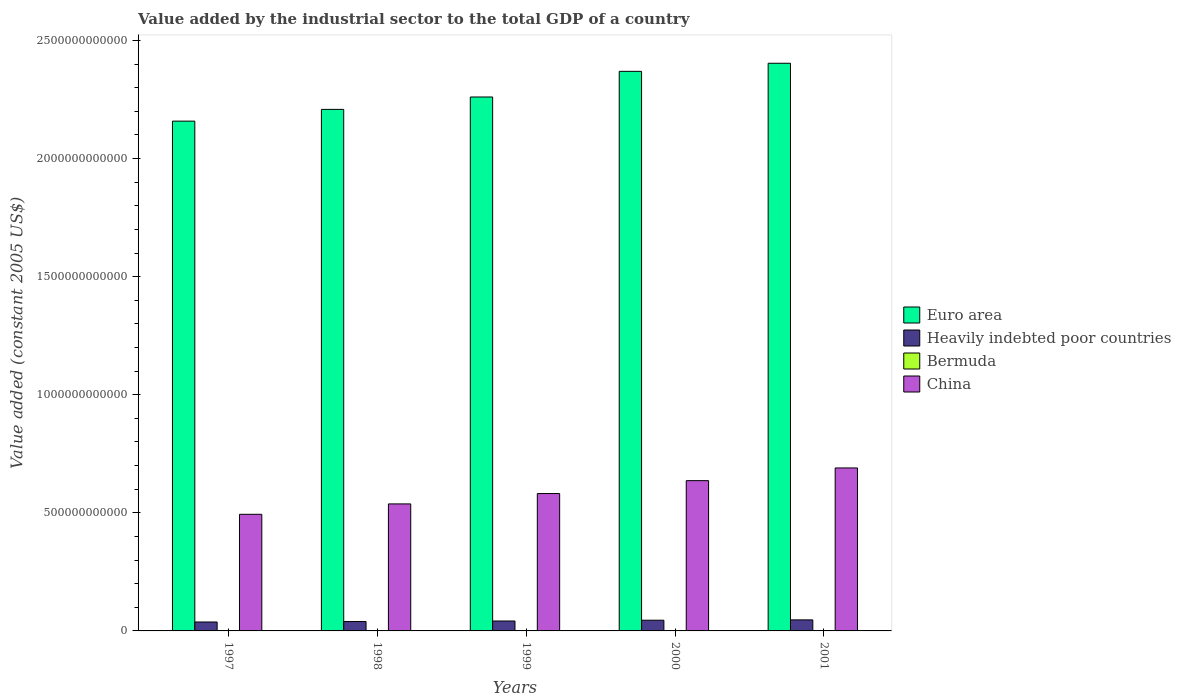How many different coloured bars are there?
Ensure brevity in your answer.  4. Are the number of bars on each tick of the X-axis equal?
Your answer should be compact. Yes. What is the label of the 3rd group of bars from the left?
Provide a short and direct response. 1999. In how many cases, is the number of bars for a given year not equal to the number of legend labels?
Keep it short and to the point. 0. What is the value added by the industrial sector in Heavily indebted poor countries in 2001?
Provide a succinct answer. 4.68e+1. Across all years, what is the maximum value added by the industrial sector in Euro area?
Your response must be concise. 2.40e+12. Across all years, what is the minimum value added by the industrial sector in Heavily indebted poor countries?
Provide a succinct answer. 3.78e+1. What is the total value added by the industrial sector in Heavily indebted poor countries in the graph?
Offer a terse response. 2.12e+11. What is the difference between the value added by the industrial sector in China in 1999 and that in 2000?
Keep it short and to the point. -5.47e+1. What is the difference between the value added by the industrial sector in Euro area in 1997 and the value added by the industrial sector in Bermuda in 1998?
Your response must be concise. 2.16e+12. What is the average value added by the industrial sector in Euro area per year?
Provide a short and direct response. 2.28e+12. In the year 2001, what is the difference between the value added by the industrial sector in Euro area and value added by the industrial sector in China?
Provide a short and direct response. 1.71e+12. What is the ratio of the value added by the industrial sector in Heavily indebted poor countries in 1997 to that in 2001?
Offer a terse response. 0.81. Is the difference between the value added by the industrial sector in Euro area in 2000 and 2001 greater than the difference between the value added by the industrial sector in China in 2000 and 2001?
Your response must be concise. Yes. What is the difference between the highest and the second highest value added by the industrial sector in China?
Offer a terse response. 5.38e+1. What is the difference between the highest and the lowest value added by the industrial sector in China?
Offer a very short reply. 1.96e+11. Is the sum of the value added by the industrial sector in Euro area in 1997 and 2001 greater than the maximum value added by the industrial sector in China across all years?
Offer a very short reply. Yes. What does the 4th bar from the left in 2001 represents?
Offer a terse response. China. What does the 3rd bar from the right in 1998 represents?
Your answer should be very brief. Heavily indebted poor countries. Is it the case that in every year, the sum of the value added by the industrial sector in Bermuda and value added by the industrial sector in Heavily indebted poor countries is greater than the value added by the industrial sector in China?
Your answer should be compact. No. What is the difference between two consecutive major ticks on the Y-axis?
Your response must be concise. 5.00e+11. Are the values on the major ticks of Y-axis written in scientific E-notation?
Keep it short and to the point. No. Does the graph contain grids?
Your answer should be very brief. No. How many legend labels are there?
Your answer should be compact. 4. What is the title of the graph?
Provide a short and direct response. Value added by the industrial sector to the total GDP of a country. Does "Tajikistan" appear as one of the legend labels in the graph?
Offer a terse response. No. What is the label or title of the Y-axis?
Make the answer very short. Value added (constant 2005 US$). What is the Value added (constant 2005 US$) of Euro area in 1997?
Your answer should be very brief. 2.16e+12. What is the Value added (constant 2005 US$) in Heavily indebted poor countries in 1997?
Ensure brevity in your answer.  3.78e+1. What is the Value added (constant 2005 US$) in Bermuda in 1997?
Ensure brevity in your answer.  3.66e+08. What is the Value added (constant 2005 US$) of China in 1997?
Give a very brief answer. 4.94e+11. What is the Value added (constant 2005 US$) of Euro area in 1998?
Your answer should be compact. 2.21e+12. What is the Value added (constant 2005 US$) of Heavily indebted poor countries in 1998?
Give a very brief answer. 3.97e+1. What is the Value added (constant 2005 US$) of Bermuda in 1998?
Make the answer very short. 3.01e+08. What is the Value added (constant 2005 US$) in China in 1998?
Give a very brief answer. 5.38e+11. What is the Value added (constant 2005 US$) in Euro area in 1999?
Make the answer very short. 2.26e+12. What is the Value added (constant 2005 US$) in Heavily indebted poor countries in 1999?
Provide a succinct answer. 4.20e+1. What is the Value added (constant 2005 US$) of Bermuda in 1999?
Ensure brevity in your answer.  4.27e+08. What is the Value added (constant 2005 US$) of China in 1999?
Ensure brevity in your answer.  5.82e+11. What is the Value added (constant 2005 US$) of Euro area in 2000?
Give a very brief answer. 2.37e+12. What is the Value added (constant 2005 US$) of Heavily indebted poor countries in 2000?
Provide a succinct answer. 4.53e+1. What is the Value added (constant 2005 US$) in Bermuda in 2000?
Provide a succinct answer. 4.76e+08. What is the Value added (constant 2005 US$) of China in 2000?
Provide a succinct answer. 6.36e+11. What is the Value added (constant 2005 US$) in Euro area in 2001?
Your answer should be compact. 2.40e+12. What is the Value added (constant 2005 US$) in Heavily indebted poor countries in 2001?
Provide a short and direct response. 4.68e+1. What is the Value added (constant 2005 US$) of Bermuda in 2001?
Offer a terse response. 4.36e+08. What is the Value added (constant 2005 US$) in China in 2001?
Your response must be concise. 6.90e+11. Across all years, what is the maximum Value added (constant 2005 US$) in Euro area?
Provide a succinct answer. 2.40e+12. Across all years, what is the maximum Value added (constant 2005 US$) of Heavily indebted poor countries?
Your answer should be compact. 4.68e+1. Across all years, what is the maximum Value added (constant 2005 US$) of Bermuda?
Your answer should be compact. 4.76e+08. Across all years, what is the maximum Value added (constant 2005 US$) of China?
Offer a very short reply. 6.90e+11. Across all years, what is the minimum Value added (constant 2005 US$) of Euro area?
Give a very brief answer. 2.16e+12. Across all years, what is the minimum Value added (constant 2005 US$) of Heavily indebted poor countries?
Your answer should be very brief. 3.78e+1. Across all years, what is the minimum Value added (constant 2005 US$) in Bermuda?
Your answer should be compact. 3.01e+08. Across all years, what is the minimum Value added (constant 2005 US$) of China?
Provide a short and direct response. 4.94e+11. What is the total Value added (constant 2005 US$) in Euro area in the graph?
Your response must be concise. 1.14e+13. What is the total Value added (constant 2005 US$) in Heavily indebted poor countries in the graph?
Offer a terse response. 2.12e+11. What is the total Value added (constant 2005 US$) in Bermuda in the graph?
Your response must be concise. 2.01e+09. What is the total Value added (constant 2005 US$) of China in the graph?
Your response must be concise. 2.94e+12. What is the difference between the Value added (constant 2005 US$) of Euro area in 1997 and that in 1998?
Give a very brief answer. -4.97e+1. What is the difference between the Value added (constant 2005 US$) of Heavily indebted poor countries in 1997 and that in 1998?
Your answer should be compact. -1.89e+09. What is the difference between the Value added (constant 2005 US$) of Bermuda in 1997 and that in 1998?
Your answer should be compact. 6.55e+07. What is the difference between the Value added (constant 2005 US$) of China in 1997 and that in 1998?
Give a very brief answer. -4.40e+1. What is the difference between the Value added (constant 2005 US$) of Euro area in 1997 and that in 1999?
Keep it short and to the point. -1.02e+11. What is the difference between the Value added (constant 2005 US$) of Heavily indebted poor countries in 1997 and that in 1999?
Your answer should be compact. -4.17e+09. What is the difference between the Value added (constant 2005 US$) in Bermuda in 1997 and that in 1999?
Offer a terse response. -6.11e+07. What is the difference between the Value added (constant 2005 US$) of China in 1997 and that in 1999?
Give a very brief answer. -8.79e+1. What is the difference between the Value added (constant 2005 US$) of Euro area in 1997 and that in 2000?
Give a very brief answer. -2.11e+11. What is the difference between the Value added (constant 2005 US$) in Heavily indebted poor countries in 1997 and that in 2000?
Provide a short and direct response. -7.52e+09. What is the difference between the Value added (constant 2005 US$) of Bermuda in 1997 and that in 2000?
Ensure brevity in your answer.  -1.10e+08. What is the difference between the Value added (constant 2005 US$) in China in 1997 and that in 2000?
Your response must be concise. -1.43e+11. What is the difference between the Value added (constant 2005 US$) in Euro area in 1997 and that in 2001?
Give a very brief answer. -2.45e+11. What is the difference between the Value added (constant 2005 US$) in Heavily indebted poor countries in 1997 and that in 2001?
Make the answer very short. -8.95e+09. What is the difference between the Value added (constant 2005 US$) in Bermuda in 1997 and that in 2001?
Keep it short and to the point. -7.04e+07. What is the difference between the Value added (constant 2005 US$) in China in 1997 and that in 2001?
Your answer should be very brief. -1.96e+11. What is the difference between the Value added (constant 2005 US$) of Euro area in 1998 and that in 1999?
Ensure brevity in your answer.  -5.25e+1. What is the difference between the Value added (constant 2005 US$) of Heavily indebted poor countries in 1998 and that in 1999?
Ensure brevity in your answer.  -2.28e+09. What is the difference between the Value added (constant 2005 US$) in Bermuda in 1998 and that in 1999?
Make the answer very short. -1.27e+08. What is the difference between the Value added (constant 2005 US$) in China in 1998 and that in 1999?
Your answer should be very brief. -4.39e+1. What is the difference between the Value added (constant 2005 US$) in Euro area in 1998 and that in 2000?
Keep it short and to the point. -1.61e+11. What is the difference between the Value added (constant 2005 US$) in Heavily indebted poor countries in 1998 and that in 2000?
Provide a short and direct response. -5.63e+09. What is the difference between the Value added (constant 2005 US$) of Bermuda in 1998 and that in 2000?
Offer a terse response. -1.75e+08. What is the difference between the Value added (constant 2005 US$) of China in 1998 and that in 2000?
Your answer should be compact. -9.85e+1. What is the difference between the Value added (constant 2005 US$) in Euro area in 1998 and that in 2001?
Provide a succinct answer. -1.95e+11. What is the difference between the Value added (constant 2005 US$) in Heavily indebted poor countries in 1998 and that in 2001?
Keep it short and to the point. -7.06e+09. What is the difference between the Value added (constant 2005 US$) in Bermuda in 1998 and that in 2001?
Offer a terse response. -1.36e+08. What is the difference between the Value added (constant 2005 US$) in China in 1998 and that in 2001?
Offer a terse response. -1.52e+11. What is the difference between the Value added (constant 2005 US$) in Euro area in 1999 and that in 2000?
Your answer should be compact. -1.09e+11. What is the difference between the Value added (constant 2005 US$) of Heavily indebted poor countries in 1999 and that in 2000?
Keep it short and to the point. -3.35e+09. What is the difference between the Value added (constant 2005 US$) of Bermuda in 1999 and that in 2000?
Your answer should be very brief. -4.87e+07. What is the difference between the Value added (constant 2005 US$) of China in 1999 and that in 2000?
Make the answer very short. -5.47e+1. What is the difference between the Value added (constant 2005 US$) in Euro area in 1999 and that in 2001?
Your answer should be compact. -1.43e+11. What is the difference between the Value added (constant 2005 US$) in Heavily indebted poor countries in 1999 and that in 2001?
Provide a short and direct response. -4.78e+09. What is the difference between the Value added (constant 2005 US$) in Bermuda in 1999 and that in 2001?
Ensure brevity in your answer.  -9.23e+06. What is the difference between the Value added (constant 2005 US$) of China in 1999 and that in 2001?
Provide a short and direct response. -1.08e+11. What is the difference between the Value added (constant 2005 US$) of Euro area in 2000 and that in 2001?
Offer a very short reply. -3.42e+1. What is the difference between the Value added (constant 2005 US$) in Heavily indebted poor countries in 2000 and that in 2001?
Offer a very short reply. -1.43e+09. What is the difference between the Value added (constant 2005 US$) of Bermuda in 2000 and that in 2001?
Keep it short and to the point. 3.95e+07. What is the difference between the Value added (constant 2005 US$) in China in 2000 and that in 2001?
Your answer should be compact. -5.38e+1. What is the difference between the Value added (constant 2005 US$) in Euro area in 1997 and the Value added (constant 2005 US$) in Heavily indebted poor countries in 1998?
Your answer should be very brief. 2.12e+12. What is the difference between the Value added (constant 2005 US$) of Euro area in 1997 and the Value added (constant 2005 US$) of Bermuda in 1998?
Provide a succinct answer. 2.16e+12. What is the difference between the Value added (constant 2005 US$) in Euro area in 1997 and the Value added (constant 2005 US$) in China in 1998?
Your answer should be compact. 1.62e+12. What is the difference between the Value added (constant 2005 US$) in Heavily indebted poor countries in 1997 and the Value added (constant 2005 US$) in Bermuda in 1998?
Give a very brief answer. 3.75e+1. What is the difference between the Value added (constant 2005 US$) in Heavily indebted poor countries in 1997 and the Value added (constant 2005 US$) in China in 1998?
Provide a short and direct response. -5.00e+11. What is the difference between the Value added (constant 2005 US$) of Bermuda in 1997 and the Value added (constant 2005 US$) of China in 1998?
Your answer should be compact. -5.37e+11. What is the difference between the Value added (constant 2005 US$) of Euro area in 1997 and the Value added (constant 2005 US$) of Heavily indebted poor countries in 1999?
Your answer should be compact. 2.12e+12. What is the difference between the Value added (constant 2005 US$) of Euro area in 1997 and the Value added (constant 2005 US$) of Bermuda in 1999?
Your answer should be very brief. 2.16e+12. What is the difference between the Value added (constant 2005 US$) of Euro area in 1997 and the Value added (constant 2005 US$) of China in 1999?
Provide a succinct answer. 1.58e+12. What is the difference between the Value added (constant 2005 US$) in Heavily indebted poor countries in 1997 and the Value added (constant 2005 US$) in Bermuda in 1999?
Ensure brevity in your answer.  3.74e+1. What is the difference between the Value added (constant 2005 US$) of Heavily indebted poor countries in 1997 and the Value added (constant 2005 US$) of China in 1999?
Make the answer very short. -5.44e+11. What is the difference between the Value added (constant 2005 US$) of Bermuda in 1997 and the Value added (constant 2005 US$) of China in 1999?
Your response must be concise. -5.81e+11. What is the difference between the Value added (constant 2005 US$) in Euro area in 1997 and the Value added (constant 2005 US$) in Heavily indebted poor countries in 2000?
Provide a succinct answer. 2.11e+12. What is the difference between the Value added (constant 2005 US$) in Euro area in 1997 and the Value added (constant 2005 US$) in Bermuda in 2000?
Your response must be concise. 2.16e+12. What is the difference between the Value added (constant 2005 US$) of Euro area in 1997 and the Value added (constant 2005 US$) of China in 2000?
Keep it short and to the point. 1.52e+12. What is the difference between the Value added (constant 2005 US$) in Heavily indebted poor countries in 1997 and the Value added (constant 2005 US$) in Bermuda in 2000?
Make the answer very short. 3.73e+1. What is the difference between the Value added (constant 2005 US$) in Heavily indebted poor countries in 1997 and the Value added (constant 2005 US$) in China in 2000?
Keep it short and to the point. -5.99e+11. What is the difference between the Value added (constant 2005 US$) in Bermuda in 1997 and the Value added (constant 2005 US$) in China in 2000?
Give a very brief answer. -6.36e+11. What is the difference between the Value added (constant 2005 US$) of Euro area in 1997 and the Value added (constant 2005 US$) of Heavily indebted poor countries in 2001?
Offer a very short reply. 2.11e+12. What is the difference between the Value added (constant 2005 US$) of Euro area in 1997 and the Value added (constant 2005 US$) of Bermuda in 2001?
Make the answer very short. 2.16e+12. What is the difference between the Value added (constant 2005 US$) in Euro area in 1997 and the Value added (constant 2005 US$) in China in 2001?
Your answer should be very brief. 1.47e+12. What is the difference between the Value added (constant 2005 US$) in Heavily indebted poor countries in 1997 and the Value added (constant 2005 US$) in Bermuda in 2001?
Provide a short and direct response. 3.74e+1. What is the difference between the Value added (constant 2005 US$) in Heavily indebted poor countries in 1997 and the Value added (constant 2005 US$) in China in 2001?
Give a very brief answer. -6.52e+11. What is the difference between the Value added (constant 2005 US$) in Bermuda in 1997 and the Value added (constant 2005 US$) in China in 2001?
Give a very brief answer. -6.90e+11. What is the difference between the Value added (constant 2005 US$) in Euro area in 1998 and the Value added (constant 2005 US$) in Heavily indebted poor countries in 1999?
Offer a terse response. 2.17e+12. What is the difference between the Value added (constant 2005 US$) of Euro area in 1998 and the Value added (constant 2005 US$) of Bermuda in 1999?
Provide a short and direct response. 2.21e+12. What is the difference between the Value added (constant 2005 US$) of Euro area in 1998 and the Value added (constant 2005 US$) of China in 1999?
Your response must be concise. 1.63e+12. What is the difference between the Value added (constant 2005 US$) in Heavily indebted poor countries in 1998 and the Value added (constant 2005 US$) in Bermuda in 1999?
Ensure brevity in your answer.  3.93e+1. What is the difference between the Value added (constant 2005 US$) in Heavily indebted poor countries in 1998 and the Value added (constant 2005 US$) in China in 1999?
Give a very brief answer. -5.42e+11. What is the difference between the Value added (constant 2005 US$) of Bermuda in 1998 and the Value added (constant 2005 US$) of China in 1999?
Offer a very short reply. -5.81e+11. What is the difference between the Value added (constant 2005 US$) of Euro area in 1998 and the Value added (constant 2005 US$) of Heavily indebted poor countries in 2000?
Offer a terse response. 2.16e+12. What is the difference between the Value added (constant 2005 US$) in Euro area in 1998 and the Value added (constant 2005 US$) in Bermuda in 2000?
Make the answer very short. 2.21e+12. What is the difference between the Value added (constant 2005 US$) in Euro area in 1998 and the Value added (constant 2005 US$) in China in 2000?
Give a very brief answer. 1.57e+12. What is the difference between the Value added (constant 2005 US$) of Heavily indebted poor countries in 1998 and the Value added (constant 2005 US$) of Bermuda in 2000?
Your response must be concise. 3.92e+1. What is the difference between the Value added (constant 2005 US$) in Heavily indebted poor countries in 1998 and the Value added (constant 2005 US$) in China in 2000?
Give a very brief answer. -5.97e+11. What is the difference between the Value added (constant 2005 US$) of Bermuda in 1998 and the Value added (constant 2005 US$) of China in 2000?
Offer a very short reply. -6.36e+11. What is the difference between the Value added (constant 2005 US$) of Euro area in 1998 and the Value added (constant 2005 US$) of Heavily indebted poor countries in 2001?
Provide a succinct answer. 2.16e+12. What is the difference between the Value added (constant 2005 US$) of Euro area in 1998 and the Value added (constant 2005 US$) of Bermuda in 2001?
Your answer should be compact. 2.21e+12. What is the difference between the Value added (constant 2005 US$) in Euro area in 1998 and the Value added (constant 2005 US$) in China in 2001?
Your answer should be compact. 1.52e+12. What is the difference between the Value added (constant 2005 US$) of Heavily indebted poor countries in 1998 and the Value added (constant 2005 US$) of Bermuda in 2001?
Provide a short and direct response. 3.93e+1. What is the difference between the Value added (constant 2005 US$) in Heavily indebted poor countries in 1998 and the Value added (constant 2005 US$) in China in 2001?
Your answer should be very brief. -6.50e+11. What is the difference between the Value added (constant 2005 US$) of Bermuda in 1998 and the Value added (constant 2005 US$) of China in 2001?
Keep it short and to the point. -6.90e+11. What is the difference between the Value added (constant 2005 US$) in Euro area in 1999 and the Value added (constant 2005 US$) in Heavily indebted poor countries in 2000?
Your response must be concise. 2.22e+12. What is the difference between the Value added (constant 2005 US$) of Euro area in 1999 and the Value added (constant 2005 US$) of Bermuda in 2000?
Make the answer very short. 2.26e+12. What is the difference between the Value added (constant 2005 US$) of Euro area in 1999 and the Value added (constant 2005 US$) of China in 2000?
Your answer should be compact. 1.62e+12. What is the difference between the Value added (constant 2005 US$) of Heavily indebted poor countries in 1999 and the Value added (constant 2005 US$) of Bermuda in 2000?
Your answer should be compact. 4.15e+1. What is the difference between the Value added (constant 2005 US$) of Heavily indebted poor countries in 1999 and the Value added (constant 2005 US$) of China in 2000?
Provide a succinct answer. -5.94e+11. What is the difference between the Value added (constant 2005 US$) of Bermuda in 1999 and the Value added (constant 2005 US$) of China in 2000?
Offer a terse response. -6.36e+11. What is the difference between the Value added (constant 2005 US$) in Euro area in 1999 and the Value added (constant 2005 US$) in Heavily indebted poor countries in 2001?
Make the answer very short. 2.21e+12. What is the difference between the Value added (constant 2005 US$) in Euro area in 1999 and the Value added (constant 2005 US$) in Bermuda in 2001?
Provide a succinct answer. 2.26e+12. What is the difference between the Value added (constant 2005 US$) of Euro area in 1999 and the Value added (constant 2005 US$) of China in 2001?
Provide a succinct answer. 1.57e+12. What is the difference between the Value added (constant 2005 US$) in Heavily indebted poor countries in 1999 and the Value added (constant 2005 US$) in Bermuda in 2001?
Offer a very short reply. 4.15e+1. What is the difference between the Value added (constant 2005 US$) of Heavily indebted poor countries in 1999 and the Value added (constant 2005 US$) of China in 2001?
Your response must be concise. -6.48e+11. What is the difference between the Value added (constant 2005 US$) of Bermuda in 1999 and the Value added (constant 2005 US$) of China in 2001?
Your answer should be very brief. -6.90e+11. What is the difference between the Value added (constant 2005 US$) of Euro area in 2000 and the Value added (constant 2005 US$) of Heavily indebted poor countries in 2001?
Make the answer very short. 2.32e+12. What is the difference between the Value added (constant 2005 US$) in Euro area in 2000 and the Value added (constant 2005 US$) in Bermuda in 2001?
Give a very brief answer. 2.37e+12. What is the difference between the Value added (constant 2005 US$) of Euro area in 2000 and the Value added (constant 2005 US$) of China in 2001?
Offer a terse response. 1.68e+12. What is the difference between the Value added (constant 2005 US$) in Heavily indebted poor countries in 2000 and the Value added (constant 2005 US$) in Bermuda in 2001?
Your answer should be very brief. 4.49e+1. What is the difference between the Value added (constant 2005 US$) in Heavily indebted poor countries in 2000 and the Value added (constant 2005 US$) in China in 2001?
Your response must be concise. -6.45e+11. What is the difference between the Value added (constant 2005 US$) of Bermuda in 2000 and the Value added (constant 2005 US$) of China in 2001?
Your answer should be very brief. -6.90e+11. What is the average Value added (constant 2005 US$) in Euro area per year?
Give a very brief answer. 2.28e+12. What is the average Value added (constant 2005 US$) of Heavily indebted poor countries per year?
Your answer should be compact. 4.23e+1. What is the average Value added (constant 2005 US$) of Bermuda per year?
Provide a succinct answer. 4.01e+08. What is the average Value added (constant 2005 US$) of China per year?
Your response must be concise. 5.88e+11. In the year 1997, what is the difference between the Value added (constant 2005 US$) of Euro area and Value added (constant 2005 US$) of Heavily indebted poor countries?
Make the answer very short. 2.12e+12. In the year 1997, what is the difference between the Value added (constant 2005 US$) in Euro area and Value added (constant 2005 US$) in Bermuda?
Give a very brief answer. 2.16e+12. In the year 1997, what is the difference between the Value added (constant 2005 US$) of Euro area and Value added (constant 2005 US$) of China?
Offer a terse response. 1.66e+12. In the year 1997, what is the difference between the Value added (constant 2005 US$) in Heavily indebted poor countries and Value added (constant 2005 US$) in Bermuda?
Offer a terse response. 3.75e+1. In the year 1997, what is the difference between the Value added (constant 2005 US$) in Heavily indebted poor countries and Value added (constant 2005 US$) in China?
Your response must be concise. -4.56e+11. In the year 1997, what is the difference between the Value added (constant 2005 US$) of Bermuda and Value added (constant 2005 US$) of China?
Your response must be concise. -4.93e+11. In the year 1998, what is the difference between the Value added (constant 2005 US$) in Euro area and Value added (constant 2005 US$) in Heavily indebted poor countries?
Ensure brevity in your answer.  2.17e+12. In the year 1998, what is the difference between the Value added (constant 2005 US$) in Euro area and Value added (constant 2005 US$) in Bermuda?
Your response must be concise. 2.21e+12. In the year 1998, what is the difference between the Value added (constant 2005 US$) of Euro area and Value added (constant 2005 US$) of China?
Keep it short and to the point. 1.67e+12. In the year 1998, what is the difference between the Value added (constant 2005 US$) of Heavily indebted poor countries and Value added (constant 2005 US$) of Bermuda?
Offer a very short reply. 3.94e+1. In the year 1998, what is the difference between the Value added (constant 2005 US$) in Heavily indebted poor countries and Value added (constant 2005 US$) in China?
Offer a terse response. -4.98e+11. In the year 1998, what is the difference between the Value added (constant 2005 US$) of Bermuda and Value added (constant 2005 US$) of China?
Offer a very short reply. -5.38e+11. In the year 1999, what is the difference between the Value added (constant 2005 US$) of Euro area and Value added (constant 2005 US$) of Heavily indebted poor countries?
Provide a short and direct response. 2.22e+12. In the year 1999, what is the difference between the Value added (constant 2005 US$) of Euro area and Value added (constant 2005 US$) of Bermuda?
Ensure brevity in your answer.  2.26e+12. In the year 1999, what is the difference between the Value added (constant 2005 US$) of Euro area and Value added (constant 2005 US$) of China?
Offer a very short reply. 1.68e+12. In the year 1999, what is the difference between the Value added (constant 2005 US$) in Heavily indebted poor countries and Value added (constant 2005 US$) in Bermuda?
Offer a terse response. 4.16e+1. In the year 1999, what is the difference between the Value added (constant 2005 US$) of Heavily indebted poor countries and Value added (constant 2005 US$) of China?
Give a very brief answer. -5.40e+11. In the year 1999, what is the difference between the Value added (constant 2005 US$) of Bermuda and Value added (constant 2005 US$) of China?
Give a very brief answer. -5.81e+11. In the year 2000, what is the difference between the Value added (constant 2005 US$) in Euro area and Value added (constant 2005 US$) in Heavily indebted poor countries?
Offer a terse response. 2.32e+12. In the year 2000, what is the difference between the Value added (constant 2005 US$) of Euro area and Value added (constant 2005 US$) of Bermuda?
Your answer should be compact. 2.37e+12. In the year 2000, what is the difference between the Value added (constant 2005 US$) in Euro area and Value added (constant 2005 US$) in China?
Offer a very short reply. 1.73e+12. In the year 2000, what is the difference between the Value added (constant 2005 US$) of Heavily indebted poor countries and Value added (constant 2005 US$) of Bermuda?
Your answer should be compact. 4.49e+1. In the year 2000, what is the difference between the Value added (constant 2005 US$) of Heavily indebted poor countries and Value added (constant 2005 US$) of China?
Your answer should be compact. -5.91e+11. In the year 2000, what is the difference between the Value added (constant 2005 US$) in Bermuda and Value added (constant 2005 US$) in China?
Keep it short and to the point. -6.36e+11. In the year 2001, what is the difference between the Value added (constant 2005 US$) in Euro area and Value added (constant 2005 US$) in Heavily indebted poor countries?
Keep it short and to the point. 2.36e+12. In the year 2001, what is the difference between the Value added (constant 2005 US$) in Euro area and Value added (constant 2005 US$) in Bermuda?
Provide a succinct answer. 2.40e+12. In the year 2001, what is the difference between the Value added (constant 2005 US$) of Euro area and Value added (constant 2005 US$) of China?
Offer a terse response. 1.71e+12. In the year 2001, what is the difference between the Value added (constant 2005 US$) in Heavily indebted poor countries and Value added (constant 2005 US$) in Bermuda?
Ensure brevity in your answer.  4.63e+1. In the year 2001, what is the difference between the Value added (constant 2005 US$) in Heavily indebted poor countries and Value added (constant 2005 US$) in China?
Your answer should be very brief. -6.43e+11. In the year 2001, what is the difference between the Value added (constant 2005 US$) in Bermuda and Value added (constant 2005 US$) in China?
Your answer should be compact. -6.90e+11. What is the ratio of the Value added (constant 2005 US$) of Euro area in 1997 to that in 1998?
Ensure brevity in your answer.  0.98. What is the ratio of the Value added (constant 2005 US$) in Heavily indebted poor countries in 1997 to that in 1998?
Keep it short and to the point. 0.95. What is the ratio of the Value added (constant 2005 US$) of Bermuda in 1997 to that in 1998?
Your answer should be compact. 1.22. What is the ratio of the Value added (constant 2005 US$) in China in 1997 to that in 1998?
Offer a very short reply. 0.92. What is the ratio of the Value added (constant 2005 US$) of Euro area in 1997 to that in 1999?
Give a very brief answer. 0.95. What is the ratio of the Value added (constant 2005 US$) of Heavily indebted poor countries in 1997 to that in 1999?
Offer a terse response. 0.9. What is the ratio of the Value added (constant 2005 US$) in Bermuda in 1997 to that in 1999?
Make the answer very short. 0.86. What is the ratio of the Value added (constant 2005 US$) in China in 1997 to that in 1999?
Your response must be concise. 0.85. What is the ratio of the Value added (constant 2005 US$) in Euro area in 1997 to that in 2000?
Provide a succinct answer. 0.91. What is the ratio of the Value added (constant 2005 US$) in Heavily indebted poor countries in 1997 to that in 2000?
Give a very brief answer. 0.83. What is the ratio of the Value added (constant 2005 US$) in Bermuda in 1997 to that in 2000?
Offer a terse response. 0.77. What is the ratio of the Value added (constant 2005 US$) of China in 1997 to that in 2000?
Make the answer very short. 0.78. What is the ratio of the Value added (constant 2005 US$) in Euro area in 1997 to that in 2001?
Your response must be concise. 0.9. What is the ratio of the Value added (constant 2005 US$) in Heavily indebted poor countries in 1997 to that in 2001?
Offer a terse response. 0.81. What is the ratio of the Value added (constant 2005 US$) in Bermuda in 1997 to that in 2001?
Give a very brief answer. 0.84. What is the ratio of the Value added (constant 2005 US$) of China in 1997 to that in 2001?
Offer a very short reply. 0.72. What is the ratio of the Value added (constant 2005 US$) in Euro area in 1998 to that in 1999?
Provide a succinct answer. 0.98. What is the ratio of the Value added (constant 2005 US$) in Heavily indebted poor countries in 1998 to that in 1999?
Offer a very short reply. 0.95. What is the ratio of the Value added (constant 2005 US$) of Bermuda in 1998 to that in 1999?
Provide a succinct answer. 0.7. What is the ratio of the Value added (constant 2005 US$) of China in 1998 to that in 1999?
Offer a terse response. 0.92. What is the ratio of the Value added (constant 2005 US$) in Euro area in 1998 to that in 2000?
Offer a very short reply. 0.93. What is the ratio of the Value added (constant 2005 US$) of Heavily indebted poor countries in 1998 to that in 2000?
Give a very brief answer. 0.88. What is the ratio of the Value added (constant 2005 US$) of Bermuda in 1998 to that in 2000?
Make the answer very short. 0.63. What is the ratio of the Value added (constant 2005 US$) of China in 1998 to that in 2000?
Offer a very short reply. 0.85. What is the ratio of the Value added (constant 2005 US$) in Euro area in 1998 to that in 2001?
Provide a succinct answer. 0.92. What is the ratio of the Value added (constant 2005 US$) in Heavily indebted poor countries in 1998 to that in 2001?
Your answer should be very brief. 0.85. What is the ratio of the Value added (constant 2005 US$) of Bermuda in 1998 to that in 2001?
Provide a succinct answer. 0.69. What is the ratio of the Value added (constant 2005 US$) of China in 1998 to that in 2001?
Your answer should be compact. 0.78. What is the ratio of the Value added (constant 2005 US$) of Euro area in 1999 to that in 2000?
Keep it short and to the point. 0.95. What is the ratio of the Value added (constant 2005 US$) of Heavily indebted poor countries in 1999 to that in 2000?
Give a very brief answer. 0.93. What is the ratio of the Value added (constant 2005 US$) of Bermuda in 1999 to that in 2000?
Your answer should be very brief. 0.9. What is the ratio of the Value added (constant 2005 US$) of China in 1999 to that in 2000?
Provide a short and direct response. 0.91. What is the ratio of the Value added (constant 2005 US$) of Euro area in 1999 to that in 2001?
Your answer should be compact. 0.94. What is the ratio of the Value added (constant 2005 US$) of Heavily indebted poor countries in 1999 to that in 2001?
Your answer should be compact. 0.9. What is the ratio of the Value added (constant 2005 US$) of Bermuda in 1999 to that in 2001?
Offer a terse response. 0.98. What is the ratio of the Value added (constant 2005 US$) of China in 1999 to that in 2001?
Give a very brief answer. 0.84. What is the ratio of the Value added (constant 2005 US$) in Euro area in 2000 to that in 2001?
Your response must be concise. 0.99. What is the ratio of the Value added (constant 2005 US$) in Heavily indebted poor countries in 2000 to that in 2001?
Your response must be concise. 0.97. What is the ratio of the Value added (constant 2005 US$) of Bermuda in 2000 to that in 2001?
Your answer should be very brief. 1.09. What is the ratio of the Value added (constant 2005 US$) of China in 2000 to that in 2001?
Your answer should be compact. 0.92. What is the difference between the highest and the second highest Value added (constant 2005 US$) of Euro area?
Give a very brief answer. 3.42e+1. What is the difference between the highest and the second highest Value added (constant 2005 US$) in Heavily indebted poor countries?
Ensure brevity in your answer.  1.43e+09. What is the difference between the highest and the second highest Value added (constant 2005 US$) of Bermuda?
Provide a short and direct response. 3.95e+07. What is the difference between the highest and the second highest Value added (constant 2005 US$) in China?
Give a very brief answer. 5.38e+1. What is the difference between the highest and the lowest Value added (constant 2005 US$) of Euro area?
Your answer should be compact. 2.45e+11. What is the difference between the highest and the lowest Value added (constant 2005 US$) of Heavily indebted poor countries?
Provide a succinct answer. 8.95e+09. What is the difference between the highest and the lowest Value added (constant 2005 US$) of Bermuda?
Make the answer very short. 1.75e+08. What is the difference between the highest and the lowest Value added (constant 2005 US$) of China?
Keep it short and to the point. 1.96e+11. 